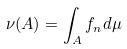<formula> <loc_0><loc_0><loc_500><loc_500>\nu ( A ) = \int _ { A } f _ { n } d \mu</formula> 